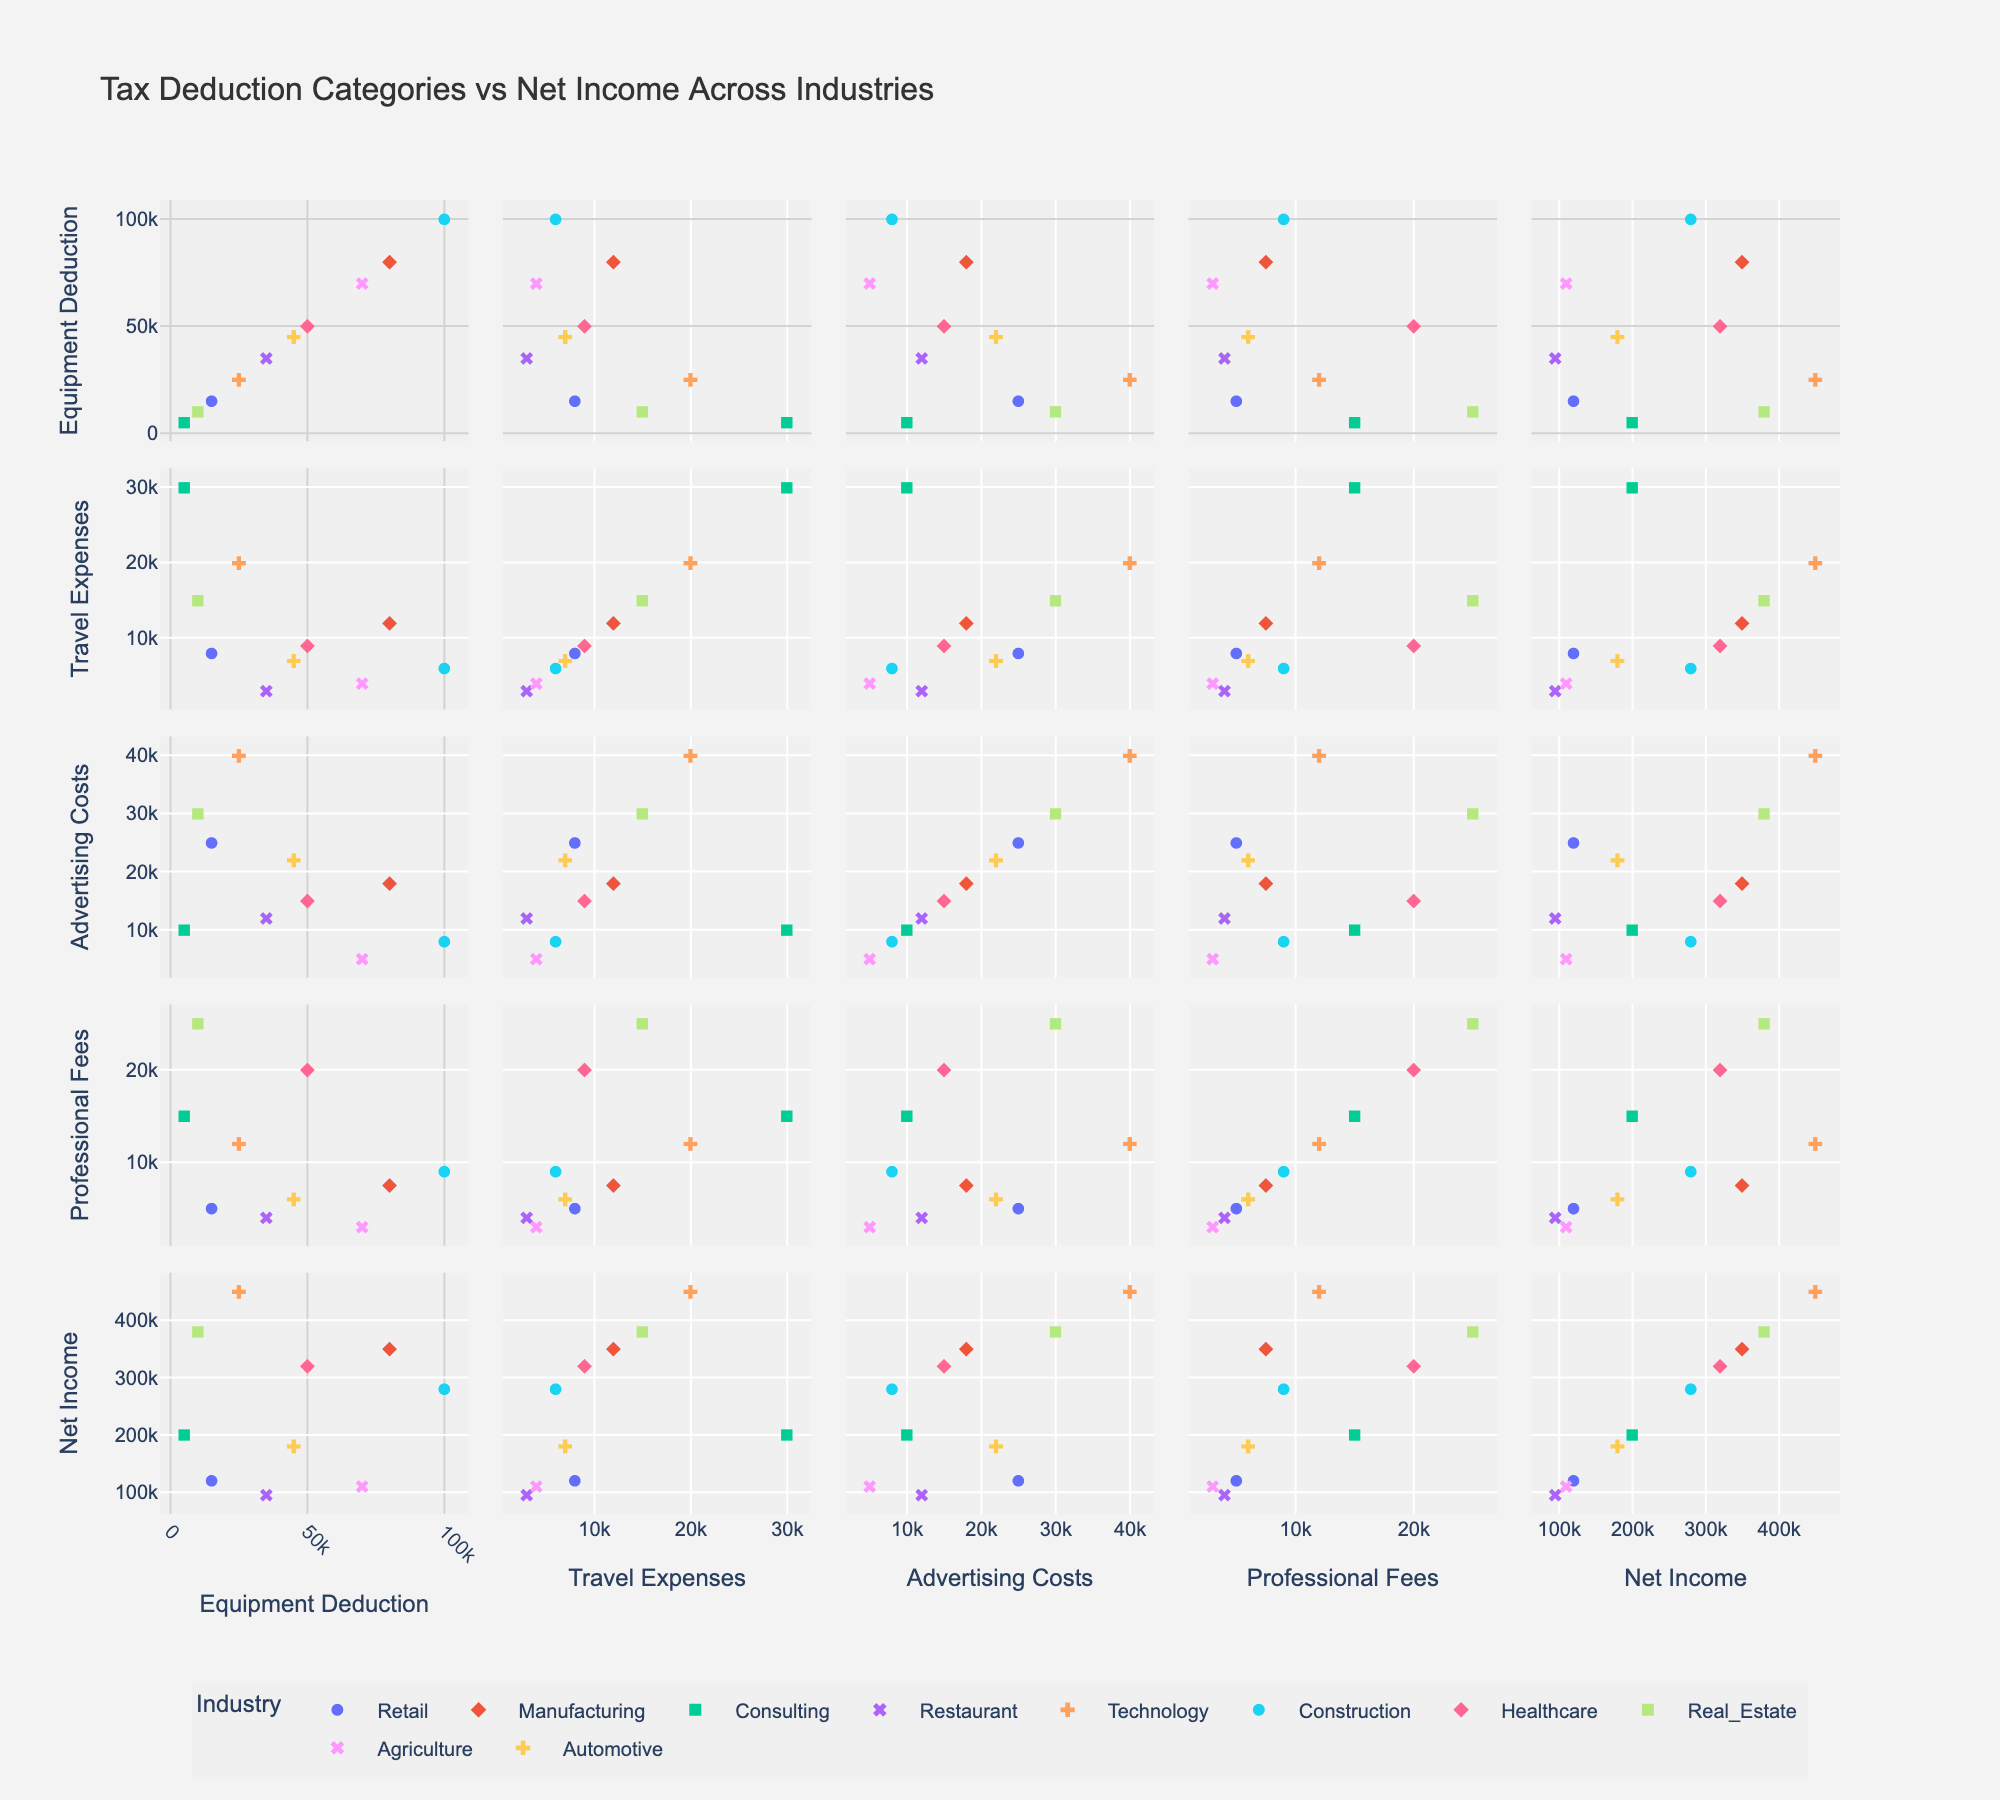How many industries are represented in the scatterplot matrix? By looking at the scatterplot matrix, note that each point is colored and symbolized by industry. Counting the unique colors and symbols will give us the number of represented industries.
Answer: 10 Which industry shows the highest Equipment Deduction? By examining the scatterplot where Equipment Deduction is plotted along the x-axis, look for the point with the highest value. The industry associated with this point will be the one with the highest Equipment Deduction.
Answer: Construction How does Net Income compare for industries with similar Equipment Deductions? Find the points with similar values on the Equipment Deductions axis and compare their positions on the Net Income axis. Observing the vertical position will show the Net Income comparison.
Answer: Various, depending on Industries Is there a strong correlation between Advertising Costs and Net Income across all industries? Look at the scatter matrix plot where Advertising Costs and Net Income are plotted against each other. A strong positive correlation would show points clustered in a trend from bottom left to top right, and a strong negative correlation would trend from top left to bottom right.
Answer: No strong correlation How are Travel Expenses distributed among different industries? Examine the scatterplots where Travel Expenses are one of the axes. Notice the spread and clustering of points of different colors and symbols to see how different industries' travel expenses are distributed.
Answer: Diverse distribution across industries What is the relationship between Professional Fees and Net Income in the Consulting industry? Locate the scatterplot comparing Professional Fees and Net Income. Examine the points specifically colored and symbolized for the Consulting industry to understand the relationship.
Answer: Positive correlation Which industries tend to have higher Advertising Costs? Look at the positions on the axis for Advertising Costs in the scatterplot matrix. Note the industries associated with the highest values on this axis.
Answer: Technology and Real Estate Are there any outliers in the Net Income data? By scanning the scatterplot matrix, identify data points that fall significantly outside the main clusters of data, particularly in the scatterplots involving Net Income.
Answer: No significant outliers Which two industries have similar Travel Expenses but different Net Incomes? Inspect the scatterplot where Travel Expenses is plotted along one axis and Net Income along the other, then identify two industries with close values on Travel Expenses but differing values on Net Income.
Answer: Retail and Healthcare 